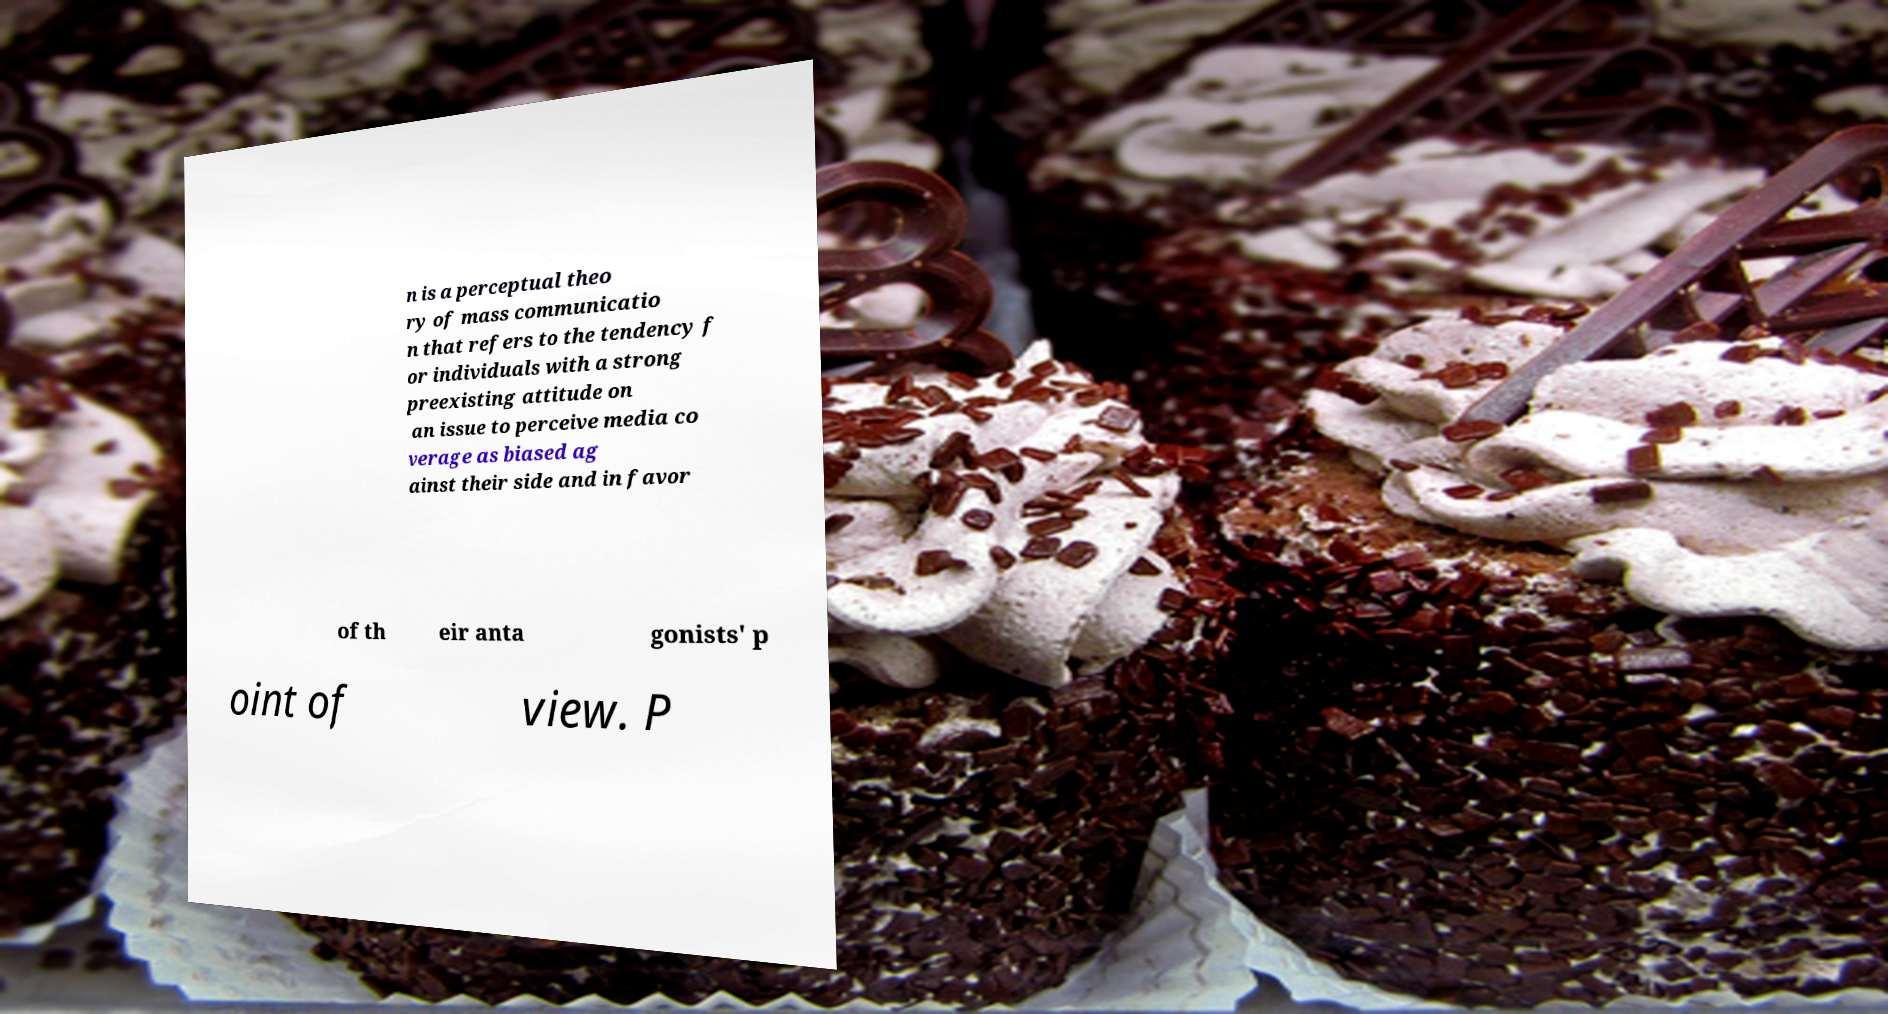Could you assist in decoding the text presented in this image and type it out clearly? n is a perceptual theo ry of mass communicatio n that refers to the tendency f or individuals with a strong preexisting attitude on an issue to perceive media co verage as biased ag ainst their side and in favor of th eir anta gonists' p oint of view. P 